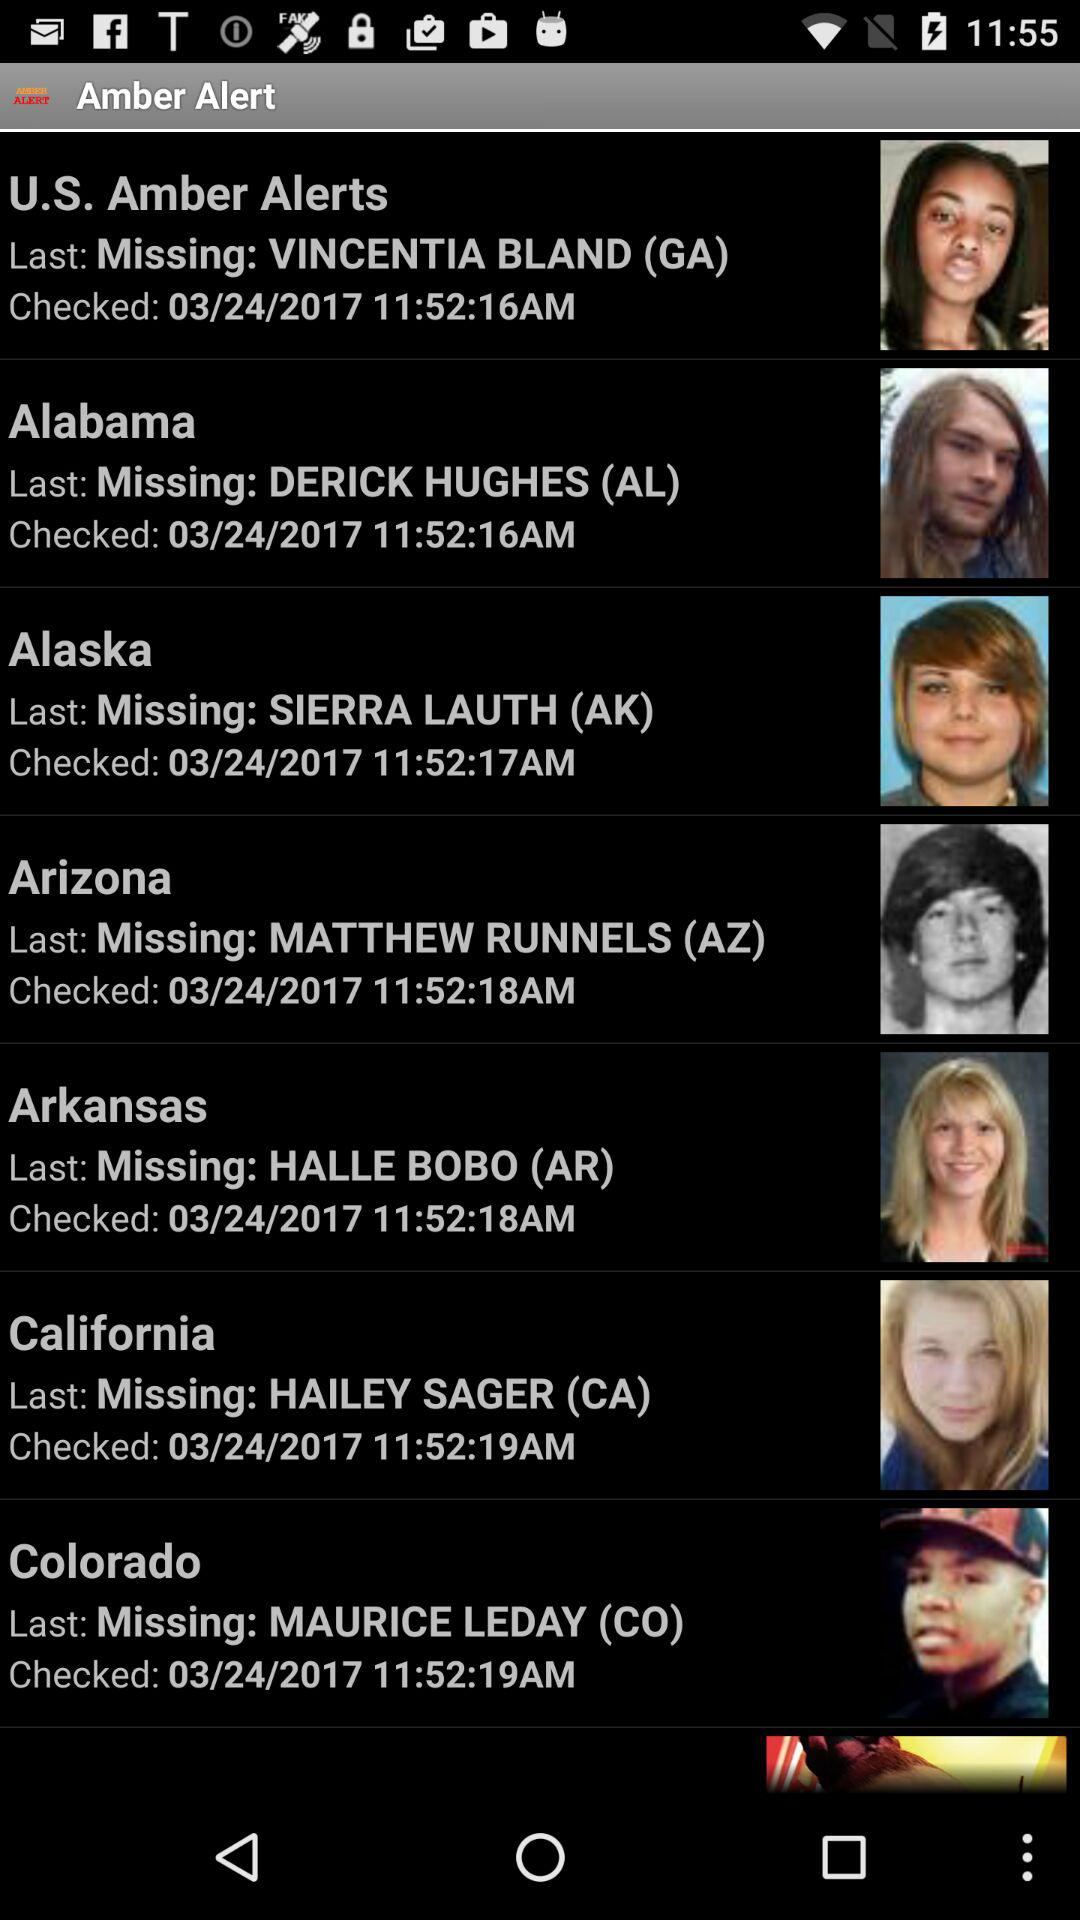From what location is Sierra Lauth missing? Sierra Lauth is missing from Alaska. 